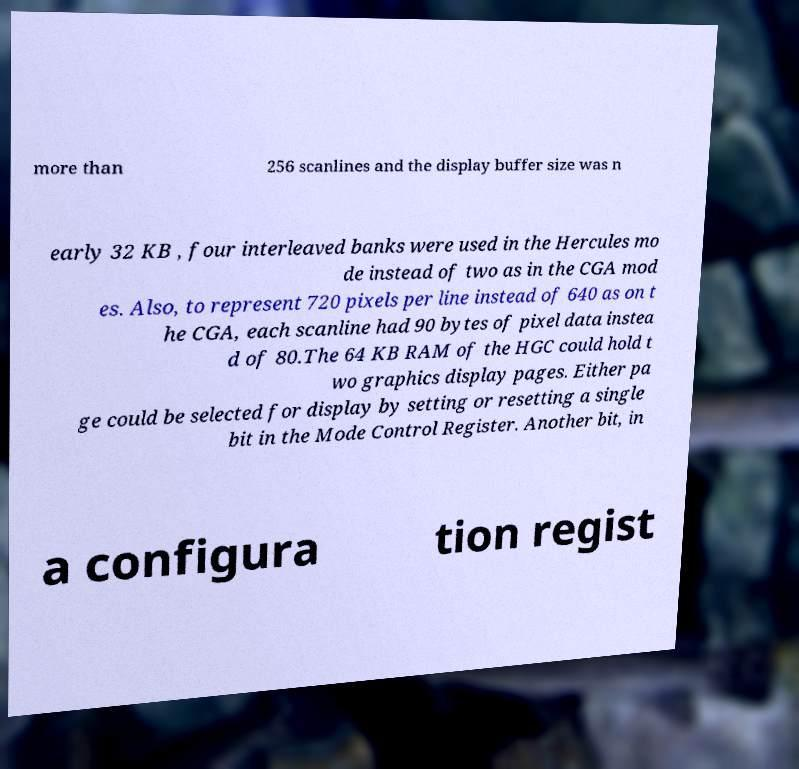Can you read and provide the text displayed in the image?This photo seems to have some interesting text. Can you extract and type it out for me? more than 256 scanlines and the display buffer size was n early 32 KB , four interleaved banks were used in the Hercules mo de instead of two as in the CGA mod es. Also, to represent 720 pixels per line instead of 640 as on t he CGA, each scanline had 90 bytes of pixel data instea d of 80.The 64 KB RAM of the HGC could hold t wo graphics display pages. Either pa ge could be selected for display by setting or resetting a single bit in the Mode Control Register. Another bit, in a configura tion regist 